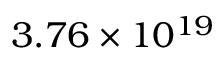Convert formula to latex. <formula><loc_0><loc_0><loc_500><loc_500>3 . 7 6 \times 1 0 ^ { 1 9 }</formula> 